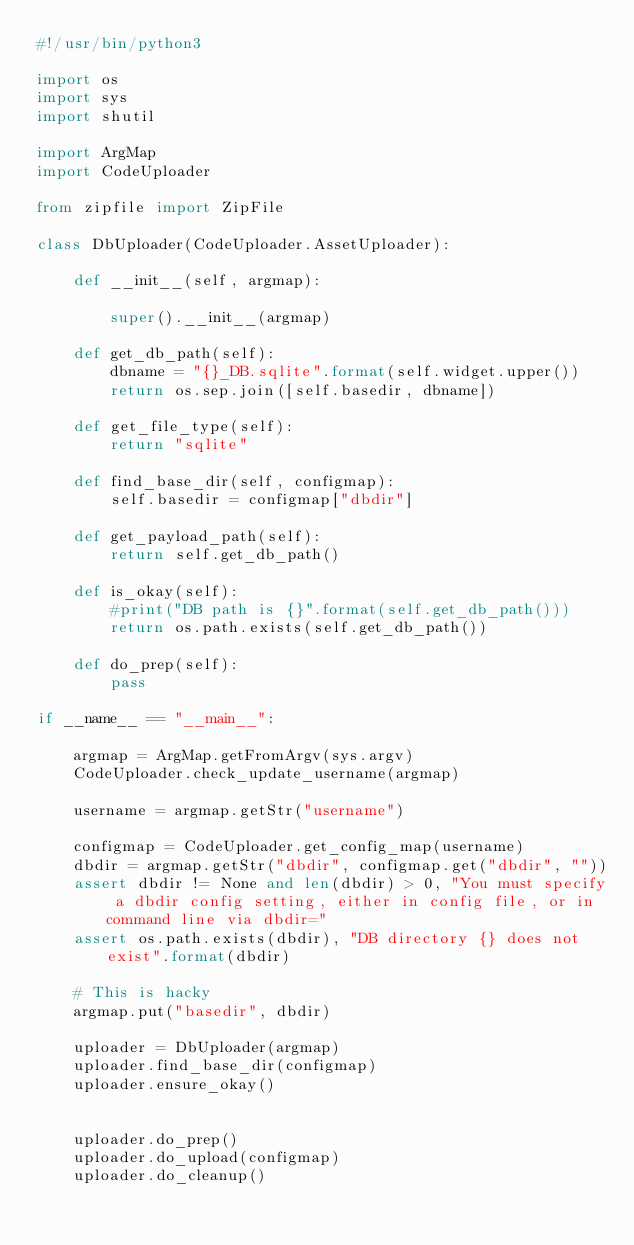<code> <loc_0><loc_0><loc_500><loc_500><_Python_>#!/usr/bin/python3

import os 
import sys
import shutil

import ArgMap
import CodeUploader

from zipfile import ZipFile
	
class DbUploader(CodeUploader.AssetUploader):
	
	def __init__(self, argmap):
		
		super().__init__(argmap)
		
	def get_db_path(self):
		dbname = "{}_DB.sqlite".format(self.widget.upper())
		return os.sep.join([self.basedir, dbname])
		
	def get_file_type(self):
		return "sqlite"		
		
	def find_base_dir(self, configmap):
		self.basedir = configmap["dbdir"]
		
	def get_payload_path(self):
		return self.get_db_path()		
		
	def is_okay(self):
		#print("DB path is {}".format(self.get_db_path()))
		return os.path.exists(self.get_db_path())	
	
	def do_prep(self):
		pass

if __name__ == "__main__":
	
	argmap = ArgMap.getFromArgv(sys.argv)
	CodeUploader.check_update_username(argmap)

	username = argmap.getStr("username")
	
	configmap = CodeUploader.get_config_map(username)
	dbdir = argmap.getStr("dbdir", configmap.get("dbdir", ""))
	assert dbdir != None and len(dbdir) > 0, "You must specify a dbdir config setting, either in config file, or in command line via dbdir="
	assert os.path.exists(dbdir), "DB directory {} does not exist".format(dbdir)
		
	# This is hacky
	argmap.put("basedir", dbdir)
	
	uploader = DbUploader(argmap)
	uploader.find_base_dir(configmap)
	uploader.ensure_okay()
	
	
	uploader.do_prep()
	uploader.do_upload(configmap)
	uploader.do_cleanup()
	
	</code> 